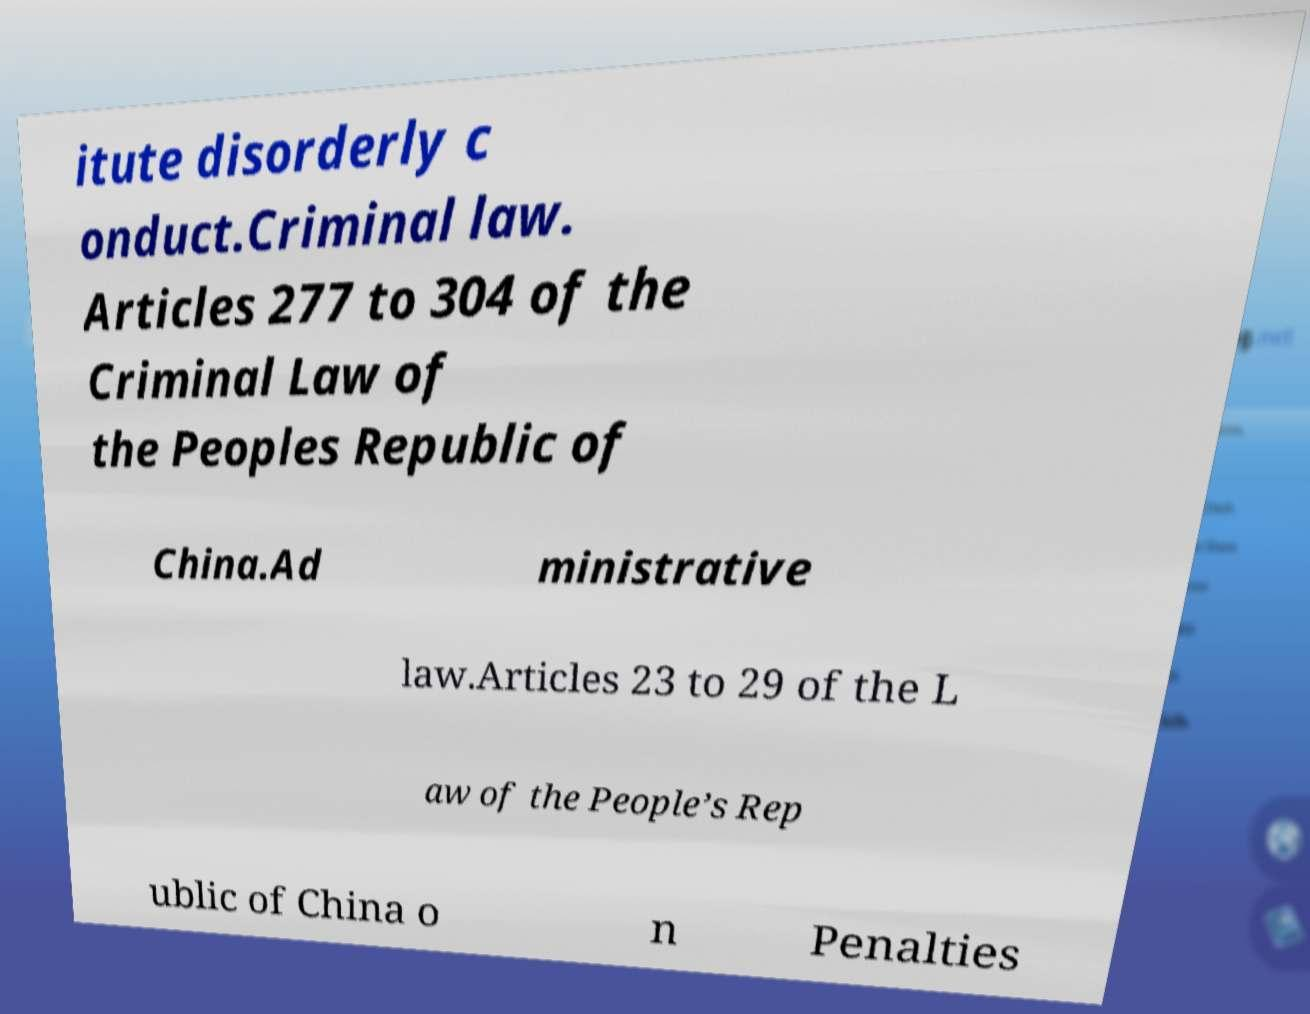Could you extract and type out the text from this image? itute disorderly c onduct.Criminal law. Articles 277 to 304 of the Criminal Law of the Peoples Republic of China.Ad ministrative law.Articles 23 to 29 of the L aw of the People’s Rep ublic of China o n Penalties 